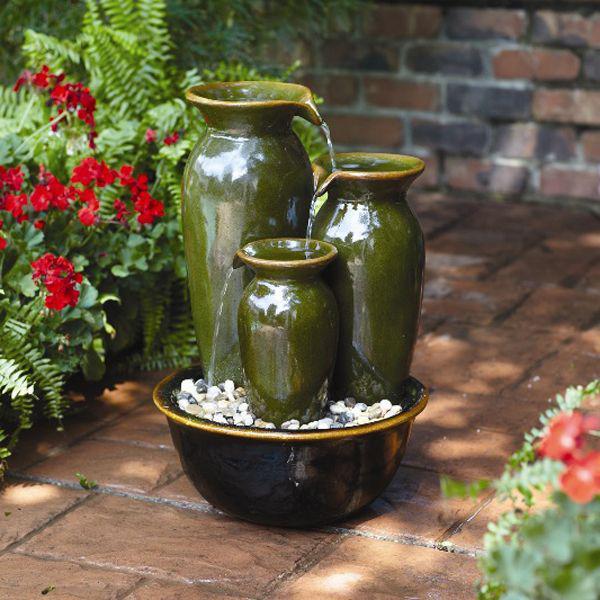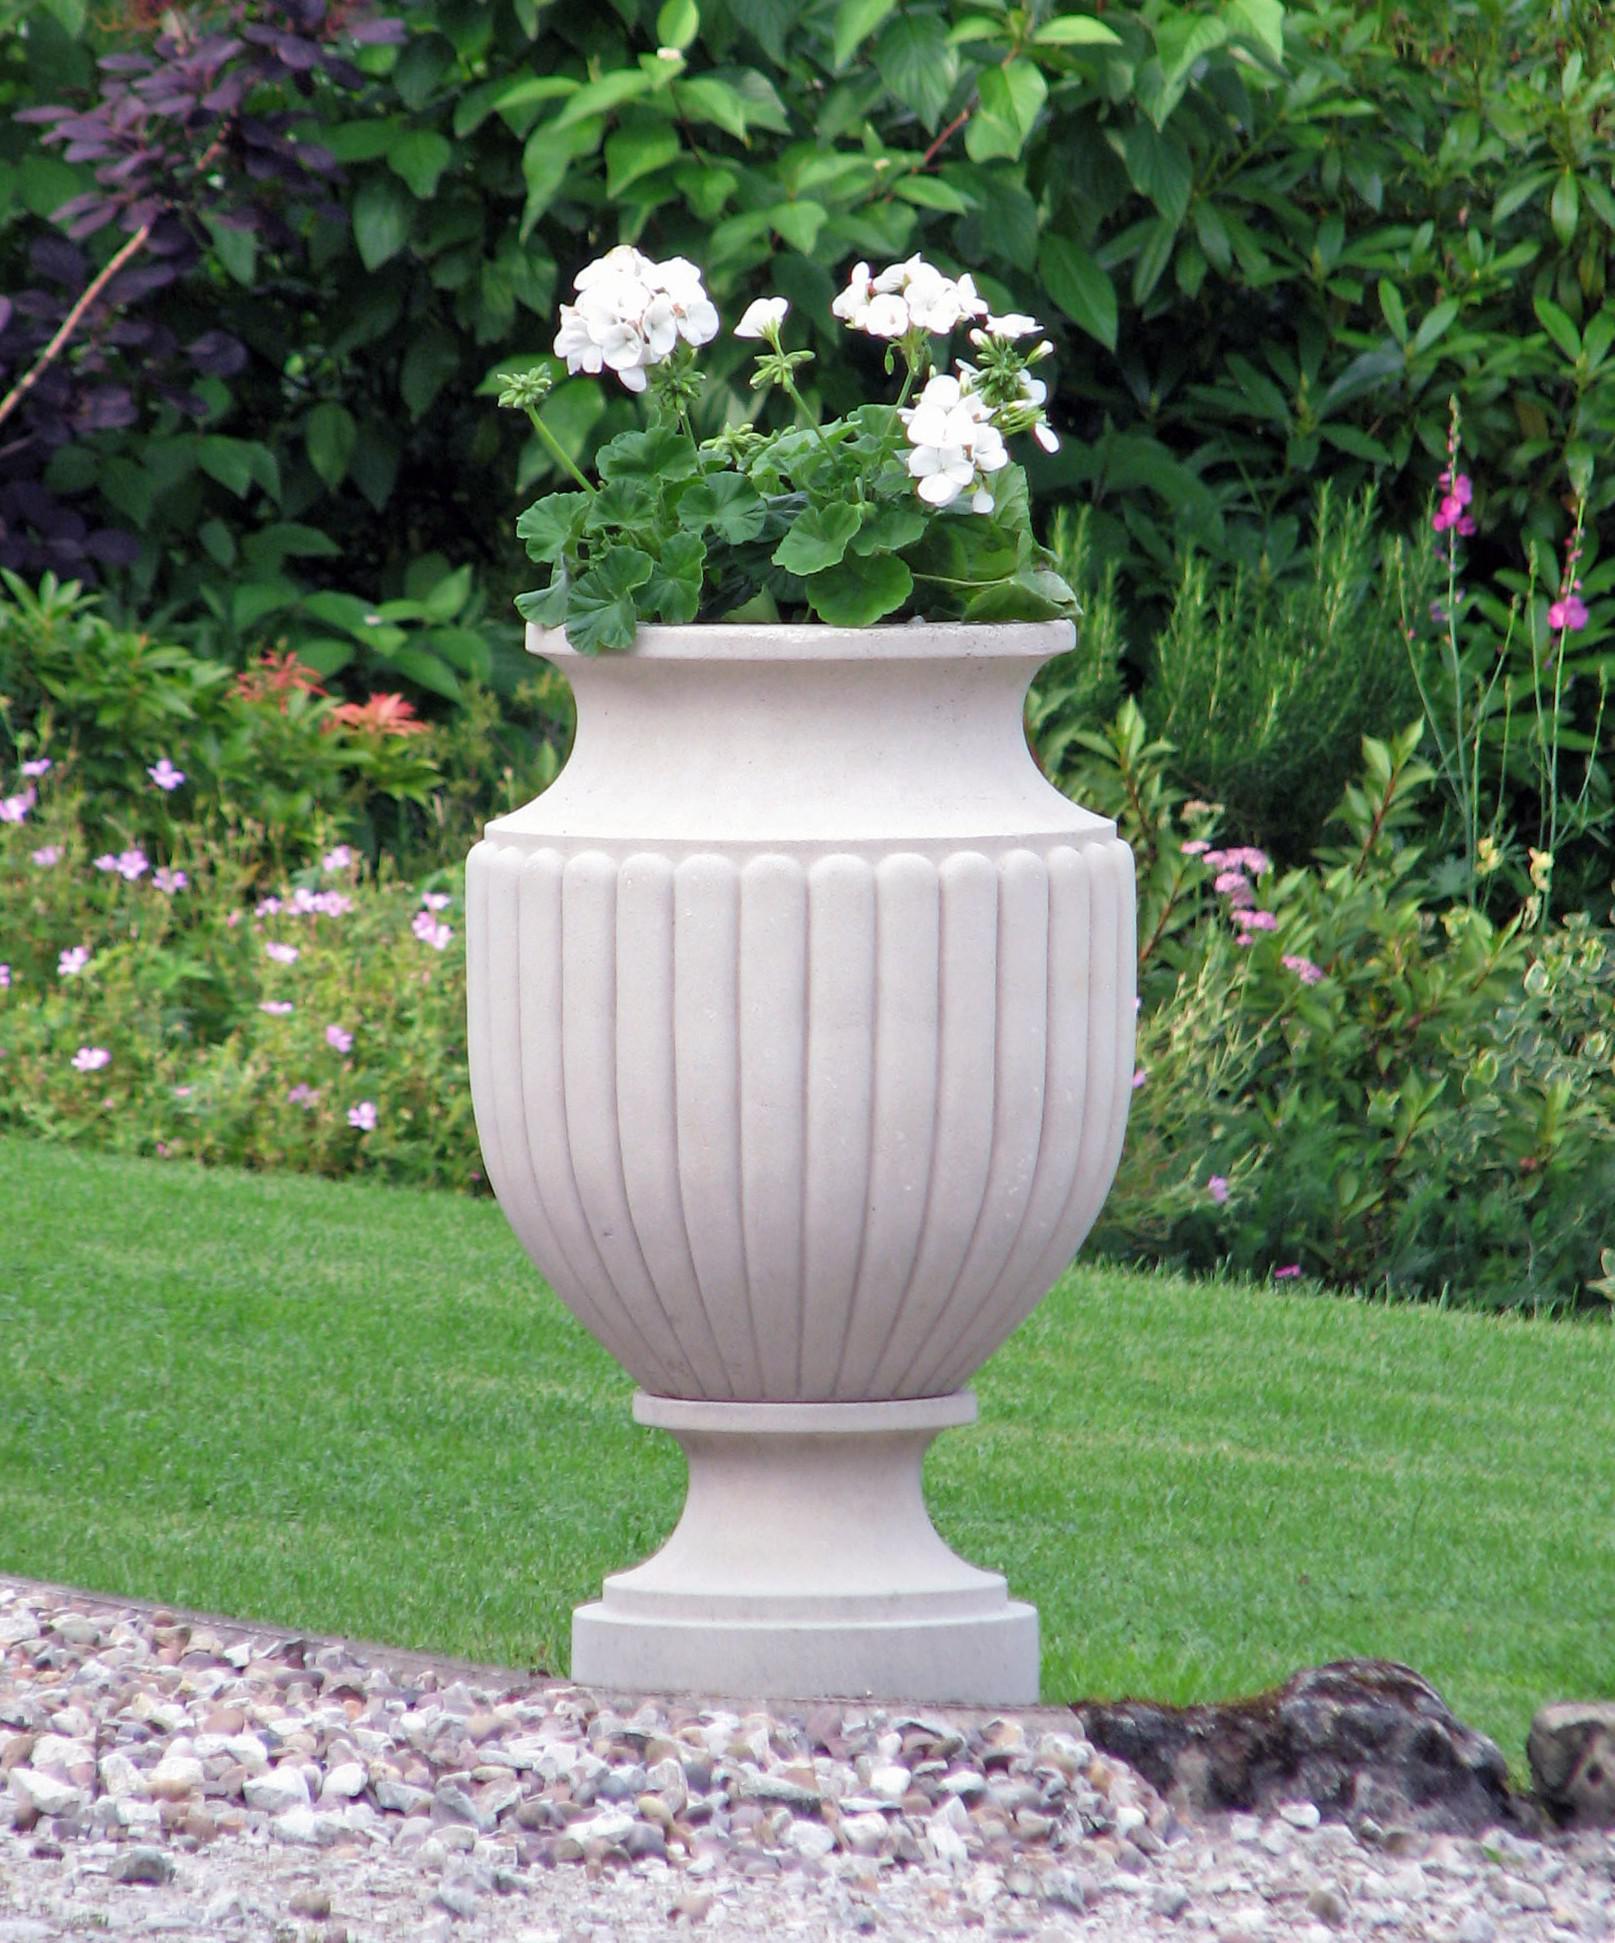The first image is the image on the left, the second image is the image on the right. Analyze the images presented: Is the assertion "There is a vase that holds a water  fountain ." valid? Answer yes or no. Yes. The first image is the image on the left, the second image is the image on the right. For the images shown, is this caption "One image includes a shiny greenish vessel used as an outdoor fountain, and the other image shows a flower-filled stone-look planter with a pedestal base." true? Answer yes or no. Yes. 